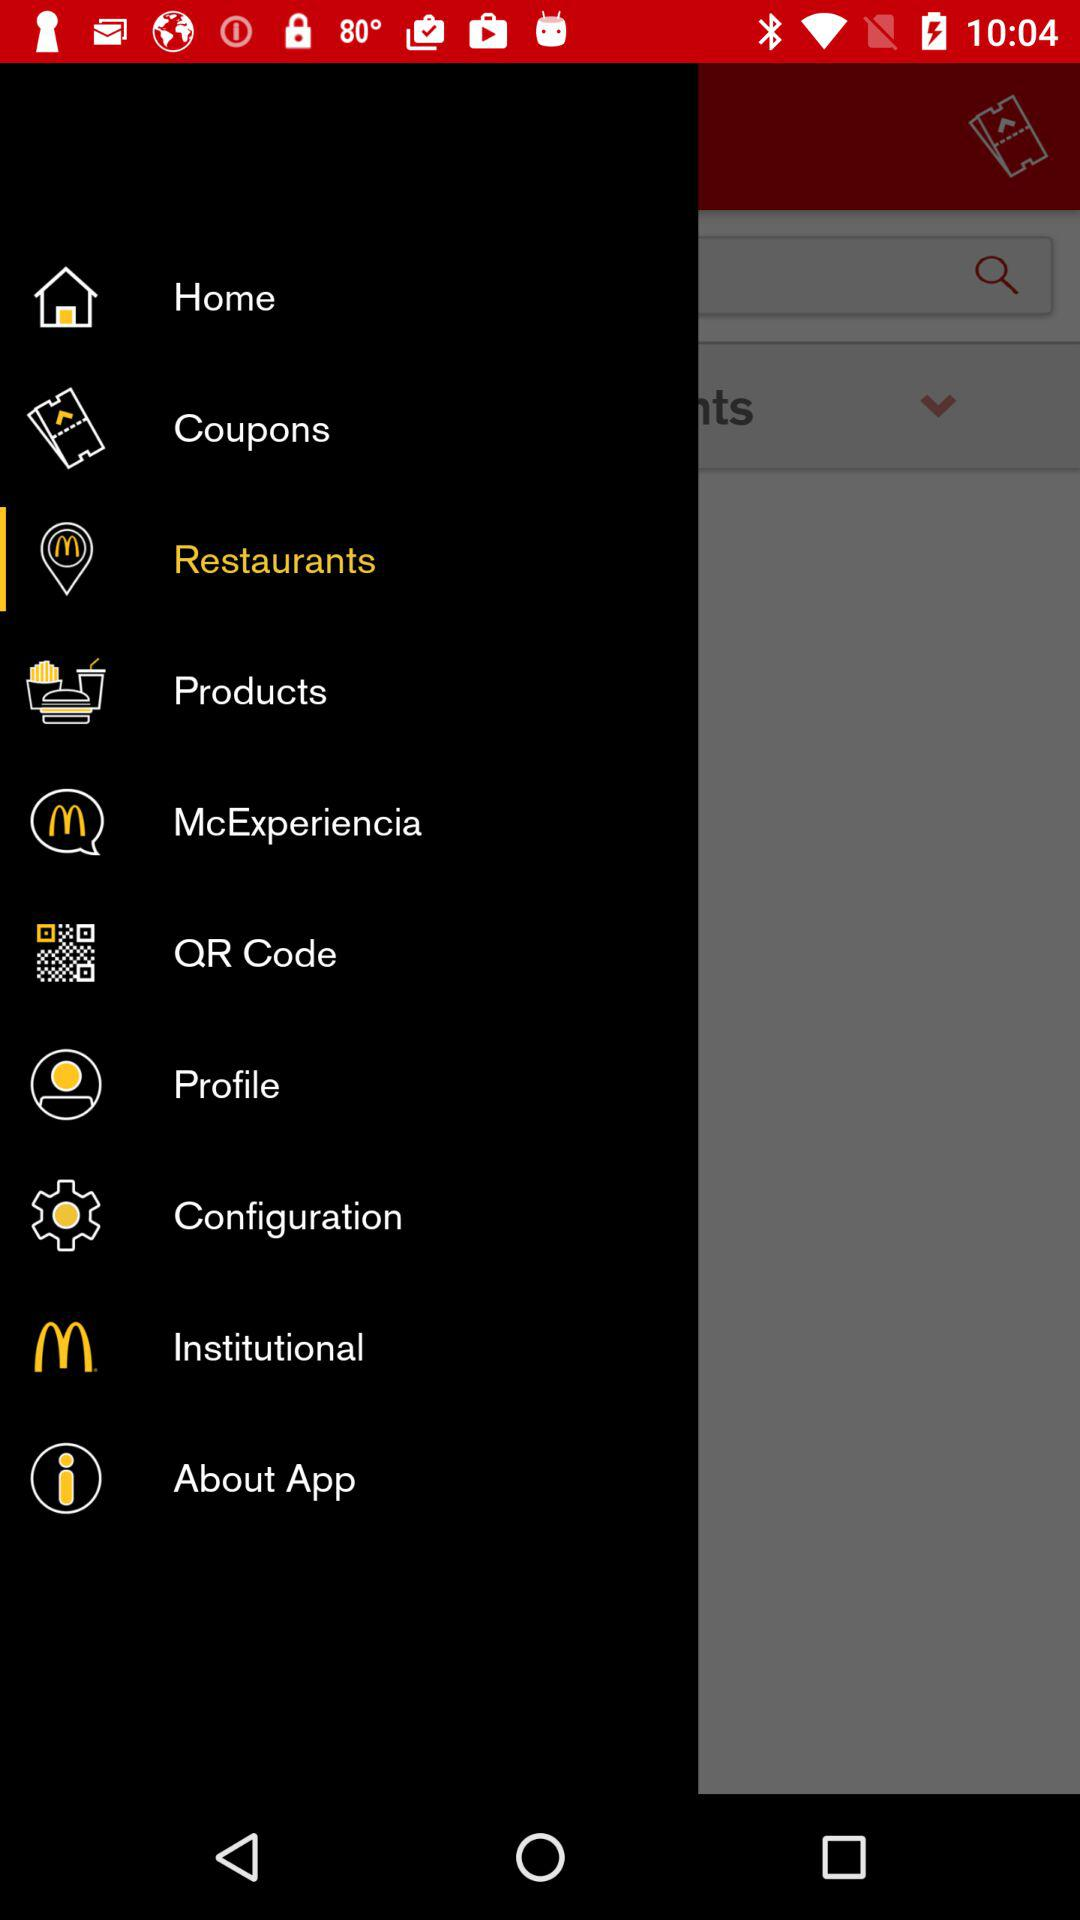Which option is selected? The selected option is "Restaurants". 